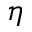Convert formula to latex. <formula><loc_0><loc_0><loc_500><loc_500>\eta</formula> 